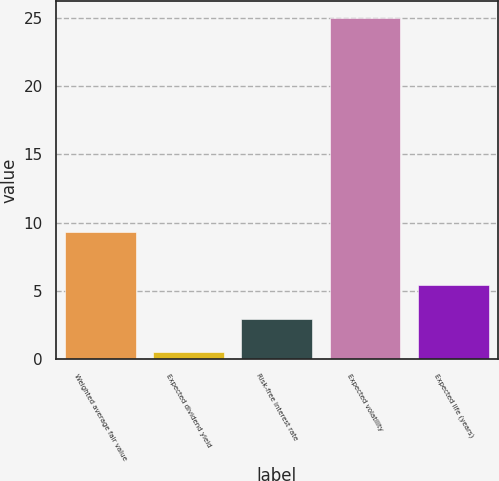<chart> <loc_0><loc_0><loc_500><loc_500><bar_chart><fcel>Weighted average fair value<fcel>Expected dividend yield<fcel>Risk-free interest rate<fcel>Expected volatility<fcel>Expected life (years)<nl><fcel>9.3<fcel>0.53<fcel>2.98<fcel>25<fcel>5.43<nl></chart> 